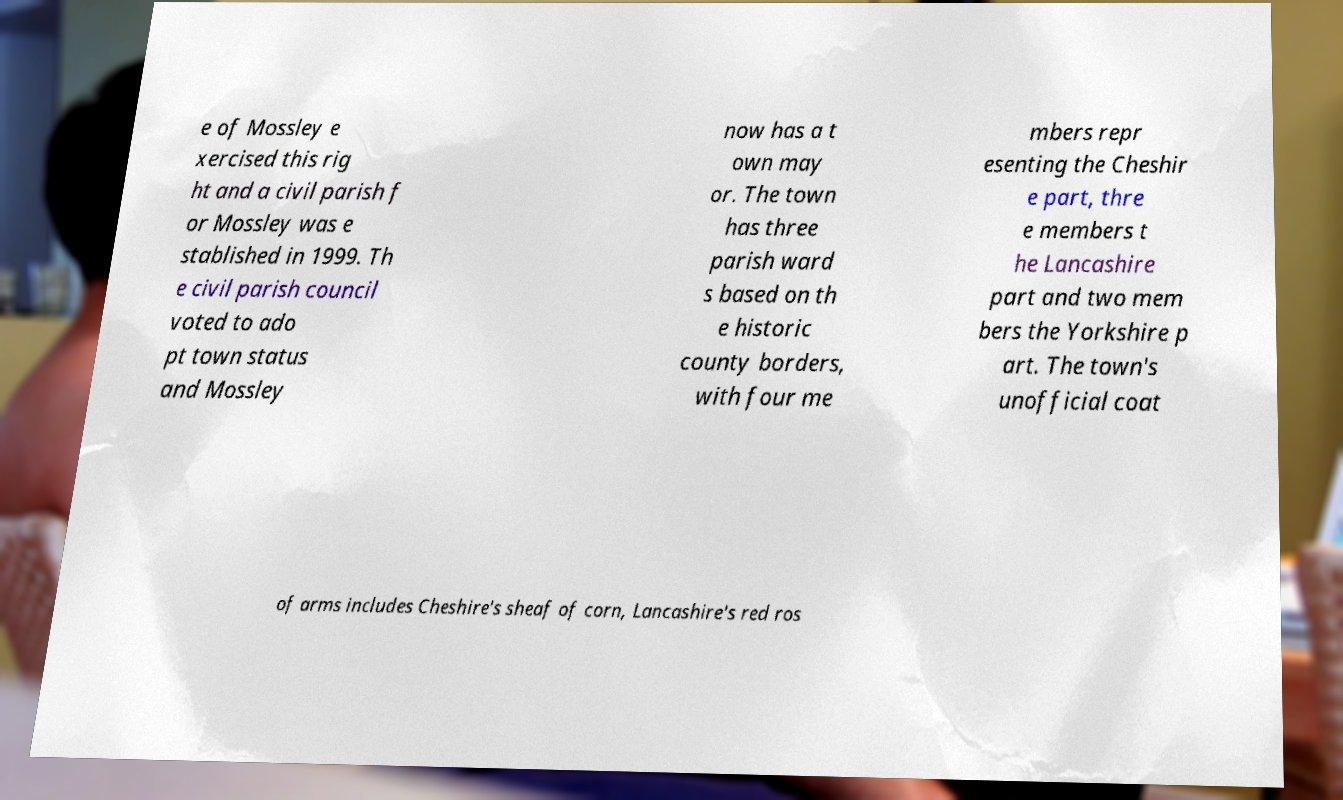I need the written content from this picture converted into text. Can you do that? e of Mossley e xercised this rig ht and a civil parish f or Mossley was e stablished in 1999. Th e civil parish council voted to ado pt town status and Mossley now has a t own may or. The town has three parish ward s based on th e historic county borders, with four me mbers repr esenting the Cheshir e part, thre e members t he Lancashire part and two mem bers the Yorkshire p art. The town's unofficial coat of arms includes Cheshire's sheaf of corn, Lancashire's red ros 